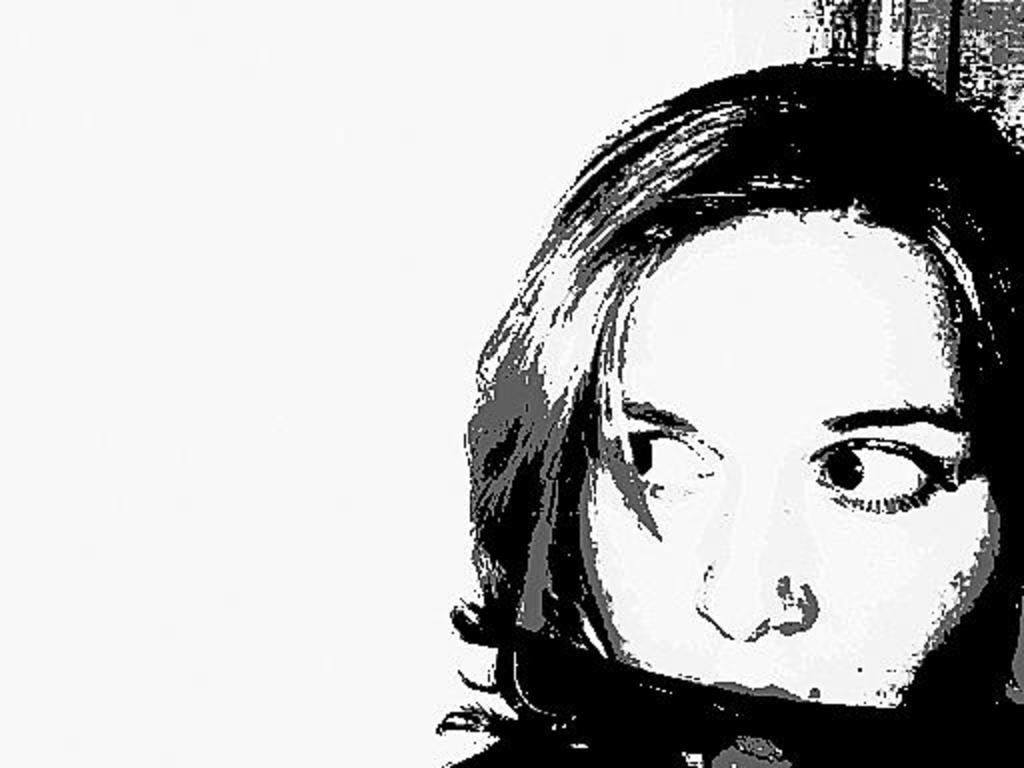What is depicted on the right side of the image? There is a drawing of a lady on the right side of the image. What color is the background of the image? The background of the image is white. What type of base is supporting the vase in the image? There is no vase present in the image, so there is no base to support it. 